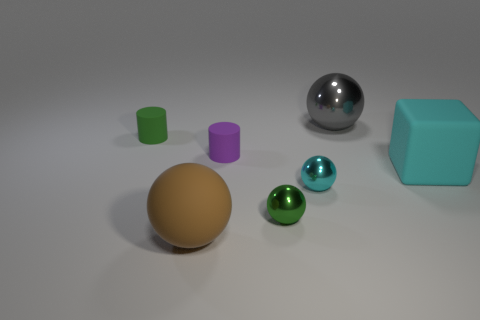What is the shape of the tiny purple object that is made of the same material as the green cylinder?
Give a very brief answer. Cylinder. Does the thing that is on the left side of the big brown rubber thing have the same shape as the cyan shiny thing?
Offer a terse response. No. There is a small green thing behind the large cyan block; what shape is it?
Provide a succinct answer. Cylinder. There is a small shiny thing that is the same color as the big block; what is its shape?
Make the answer very short. Sphere. What number of blue cubes are the same size as the cyan matte cube?
Offer a very short reply. 0. What is the color of the big matte block?
Your response must be concise. Cyan. Is the color of the large metal ball the same as the small matte cylinder right of the large brown matte sphere?
Your answer should be very brief. No. What size is the cyan thing that is made of the same material as the small green ball?
Give a very brief answer. Small. Is there another large matte cube of the same color as the block?
Make the answer very short. No. How many objects are either big objects that are on the left side of the large shiny ball or big matte balls?
Provide a short and direct response. 1. 